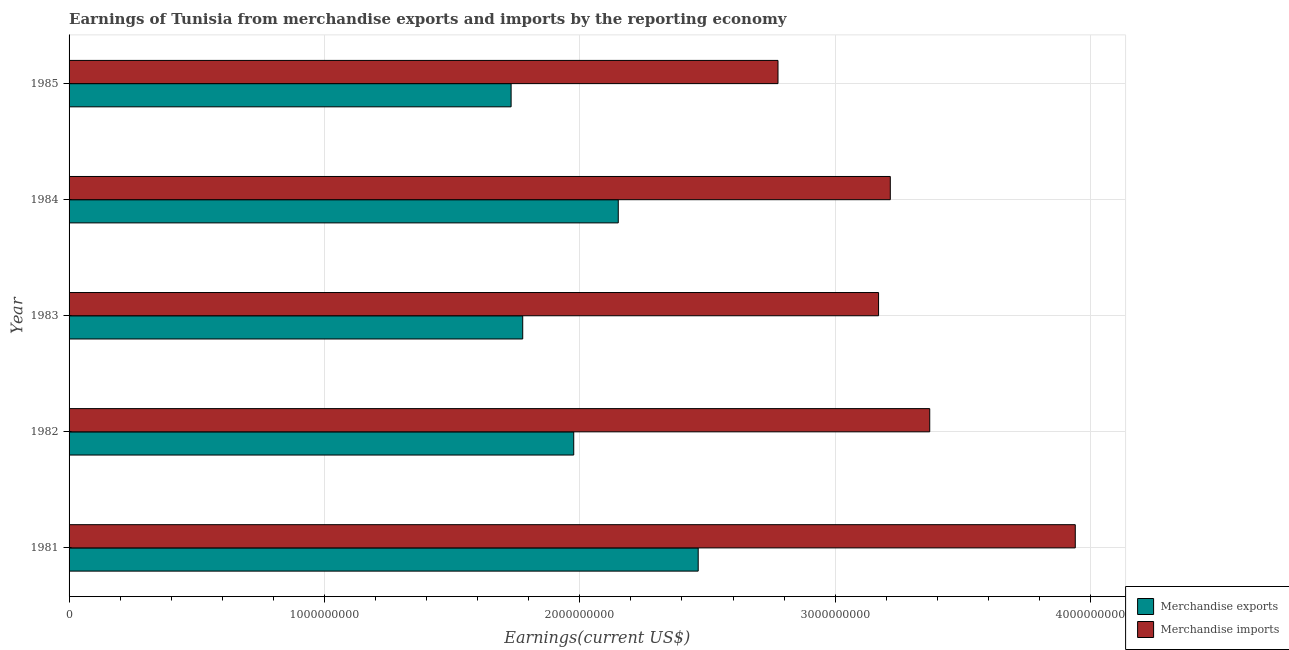How many different coloured bars are there?
Ensure brevity in your answer.  2. How many bars are there on the 2nd tick from the top?
Make the answer very short. 2. How many bars are there on the 4th tick from the bottom?
Your answer should be compact. 2. What is the label of the 1st group of bars from the top?
Keep it short and to the point. 1985. In how many cases, is the number of bars for a given year not equal to the number of legend labels?
Provide a succinct answer. 0. What is the earnings from merchandise exports in 1984?
Offer a very short reply. 2.15e+09. Across all years, what is the maximum earnings from merchandise exports?
Make the answer very short. 2.46e+09. Across all years, what is the minimum earnings from merchandise imports?
Your answer should be very brief. 2.78e+09. In which year was the earnings from merchandise exports maximum?
Provide a succinct answer. 1981. In which year was the earnings from merchandise imports minimum?
Your answer should be very brief. 1985. What is the total earnings from merchandise imports in the graph?
Provide a short and direct response. 1.65e+1. What is the difference between the earnings from merchandise exports in 1983 and that in 1985?
Your answer should be very brief. 4.54e+07. What is the difference between the earnings from merchandise exports in 1981 and the earnings from merchandise imports in 1984?
Ensure brevity in your answer.  -7.52e+08. What is the average earnings from merchandise imports per year?
Your answer should be very brief. 3.29e+09. In the year 1982, what is the difference between the earnings from merchandise exports and earnings from merchandise imports?
Offer a terse response. -1.39e+09. In how many years, is the earnings from merchandise imports greater than 1400000000 US$?
Your answer should be very brief. 5. What is the ratio of the earnings from merchandise exports in 1982 to that in 1985?
Offer a very short reply. 1.14. What is the difference between the highest and the second highest earnings from merchandise exports?
Provide a short and direct response. 3.13e+08. What is the difference between the highest and the lowest earnings from merchandise exports?
Provide a succinct answer. 7.33e+08. What does the 2nd bar from the bottom in 1981 represents?
Keep it short and to the point. Merchandise imports. How many bars are there?
Provide a short and direct response. 10. Does the graph contain any zero values?
Ensure brevity in your answer.  No. Does the graph contain grids?
Provide a succinct answer. Yes. How many legend labels are there?
Your response must be concise. 2. How are the legend labels stacked?
Make the answer very short. Vertical. What is the title of the graph?
Your answer should be very brief. Earnings of Tunisia from merchandise exports and imports by the reporting economy. What is the label or title of the X-axis?
Make the answer very short. Earnings(current US$). What is the Earnings(current US$) in Merchandise exports in 1981?
Your response must be concise. 2.46e+09. What is the Earnings(current US$) in Merchandise imports in 1981?
Your response must be concise. 3.94e+09. What is the Earnings(current US$) of Merchandise exports in 1982?
Make the answer very short. 1.98e+09. What is the Earnings(current US$) in Merchandise imports in 1982?
Your answer should be very brief. 3.37e+09. What is the Earnings(current US$) in Merchandise exports in 1983?
Give a very brief answer. 1.78e+09. What is the Earnings(current US$) in Merchandise imports in 1983?
Offer a terse response. 3.17e+09. What is the Earnings(current US$) in Merchandise exports in 1984?
Give a very brief answer. 2.15e+09. What is the Earnings(current US$) of Merchandise imports in 1984?
Offer a terse response. 3.22e+09. What is the Earnings(current US$) of Merchandise exports in 1985?
Provide a short and direct response. 1.73e+09. What is the Earnings(current US$) in Merchandise imports in 1985?
Offer a terse response. 2.78e+09. Across all years, what is the maximum Earnings(current US$) of Merchandise exports?
Make the answer very short. 2.46e+09. Across all years, what is the maximum Earnings(current US$) of Merchandise imports?
Your answer should be compact. 3.94e+09. Across all years, what is the minimum Earnings(current US$) in Merchandise exports?
Provide a short and direct response. 1.73e+09. Across all years, what is the minimum Earnings(current US$) of Merchandise imports?
Your answer should be compact. 2.78e+09. What is the total Earnings(current US$) of Merchandise exports in the graph?
Ensure brevity in your answer.  1.01e+1. What is the total Earnings(current US$) of Merchandise imports in the graph?
Your answer should be very brief. 1.65e+1. What is the difference between the Earnings(current US$) in Merchandise exports in 1981 and that in 1982?
Provide a succinct answer. 4.87e+08. What is the difference between the Earnings(current US$) of Merchandise imports in 1981 and that in 1982?
Ensure brevity in your answer.  5.70e+08. What is the difference between the Earnings(current US$) of Merchandise exports in 1981 and that in 1983?
Offer a very short reply. 6.87e+08. What is the difference between the Earnings(current US$) in Merchandise imports in 1981 and that in 1983?
Provide a short and direct response. 7.70e+08. What is the difference between the Earnings(current US$) of Merchandise exports in 1981 and that in 1984?
Give a very brief answer. 3.13e+08. What is the difference between the Earnings(current US$) of Merchandise imports in 1981 and that in 1984?
Make the answer very short. 7.24e+08. What is the difference between the Earnings(current US$) of Merchandise exports in 1981 and that in 1985?
Give a very brief answer. 7.33e+08. What is the difference between the Earnings(current US$) of Merchandise imports in 1981 and that in 1985?
Keep it short and to the point. 1.16e+09. What is the difference between the Earnings(current US$) of Merchandise exports in 1982 and that in 1983?
Give a very brief answer. 2.00e+08. What is the difference between the Earnings(current US$) of Merchandise imports in 1982 and that in 1983?
Provide a short and direct response. 2.00e+08. What is the difference between the Earnings(current US$) of Merchandise exports in 1982 and that in 1984?
Offer a very short reply. -1.74e+08. What is the difference between the Earnings(current US$) in Merchandise imports in 1982 and that in 1984?
Your answer should be compact. 1.54e+08. What is the difference between the Earnings(current US$) in Merchandise exports in 1982 and that in 1985?
Your answer should be very brief. 2.45e+08. What is the difference between the Earnings(current US$) of Merchandise imports in 1982 and that in 1985?
Offer a very short reply. 5.94e+08. What is the difference between the Earnings(current US$) of Merchandise exports in 1983 and that in 1984?
Provide a succinct answer. -3.74e+08. What is the difference between the Earnings(current US$) of Merchandise imports in 1983 and that in 1984?
Offer a terse response. -4.59e+07. What is the difference between the Earnings(current US$) in Merchandise exports in 1983 and that in 1985?
Keep it short and to the point. 4.54e+07. What is the difference between the Earnings(current US$) in Merchandise imports in 1983 and that in 1985?
Your answer should be compact. 3.94e+08. What is the difference between the Earnings(current US$) of Merchandise exports in 1984 and that in 1985?
Keep it short and to the point. 4.20e+08. What is the difference between the Earnings(current US$) in Merchandise imports in 1984 and that in 1985?
Keep it short and to the point. 4.40e+08. What is the difference between the Earnings(current US$) in Merchandise exports in 1981 and the Earnings(current US$) in Merchandise imports in 1982?
Make the answer very short. -9.07e+08. What is the difference between the Earnings(current US$) in Merchandise exports in 1981 and the Earnings(current US$) in Merchandise imports in 1983?
Keep it short and to the point. -7.06e+08. What is the difference between the Earnings(current US$) in Merchandise exports in 1981 and the Earnings(current US$) in Merchandise imports in 1984?
Provide a succinct answer. -7.52e+08. What is the difference between the Earnings(current US$) of Merchandise exports in 1981 and the Earnings(current US$) of Merchandise imports in 1985?
Make the answer very short. -3.12e+08. What is the difference between the Earnings(current US$) in Merchandise exports in 1982 and the Earnings(current US$) in Merchandise imports in 1983?
Keep it short and to the point. -1.19e+09. What is the difference between the Earnings(current US$) of Merchandise exports in 1982 and the Earnings(current US$) of Merchandise imports in 1984?
Offer a very short reply. -1.24e+09. What is the difference between the Earnings(current US$) of Merchandise exports in 1982 and the Earnings(current US$) of Merchandise imports in 1985?
Your response must be concise. -8.00e+08. What is the difference between the Earnings(current US$) of Merchandise exports in 1983 and the Earnings(current US$) of Merchandise imports in 1984?
Provide a short and direct response. -1.44e+09. What is the difference between the Earnings(current US$) of Merchandise exports in 1983 and the Earnings(current US$) of Merchandise imports in 1985?
Your response must be concise. -1.00e+09. What is the difference between the Earnings(current US$) of Merchandise exports in 1984 and the Earnings(current US$) of Merchandise imports in 1985?
Make the answer very short. -6.25e+08. What is the average Earnings(current US$) of Merchandise exports per year?
Offer a very short reply. 2.02e+09. What is the average Earnings(current US$) in Merchandise imports per year?
Ensure brevity in your answer.  3.29e+09. In the year 1981, what is the difference between the Earnings(current US$) in Merchandise exports and Earnings(current US$) in Merchandise imports?
Your answer should be very brief. -1.48e+09. In the year 1982, what is the difference between the Earnings(current US$) of Merchandise exports and Earnings(current US$) of Merchandise imports?
Provide a succinct answer. -1.39e+09. In the year 1983, what is the difference between the Earnings(current US$) in Merchandise exports and Earnings(current US$) in Merchandise imports?
Give a very brief answer. -1.39e+09. In the year 1984, what is the difference between the Earnings(current US$) of Merchandise exports and Earnings(current US$) of Merchandise imports?
Ensure brevity in your answer.  -1.07e+09. In the year 1985, what is the difference between the Earnings(current US$) of Merchandise exports and Earnings(current US$) of Merchandise imports?
Ensure brevity in your answer.  -1.05e+09. What is the ratio of the Earnings(current US$) in Merchandise exports in 1981 to that in 1982?
Your answer should be very brief. 1.25. What is the ratio of the Earnings(current US$) of Merchandise imports in 1981 to that in 1982?
Provide a succinct answer. 1.17. What is the ratio of the Earnings(current US$) of Merchandise exports in 1981 to that in 1983?
Your response must be concise. 1.39. What is the ratio of the Earnings(current US$) of Merchandise imports in 1981 to that in 1983?
Make the answer very short. 1.24. What is the ratio of the Earnings(current US$) in Merchandise exports in 1981 to that in 1984?
Your answer should be very brief. 1.15. What is the ratio of the Earnings(current US$) of Merchandise imports in 1981 to that in 1984?
Provide a short and direct response. 1.23. What is the ratio of the Earnings(current US$) in Merchandise exports in 1981 to that in 1985?
Keep it short and to the point. 1.42. What is the ratio of the Earnings(current US$) in Merchandise imports in 1981 to that in 1985?
Ensure brevity in your answer.  1.42. What is the ratio of the Earnings(current US$) of Merchandise exports in 1982 to that in 1983?
Provide a succinct answer. 1.11. What is the ratio of the Earnings(current US$) in Merchandise imports in 1982 to that in 1983?
Offer a terse response. 1.06. What is the ratio of the Earnings(current US$) in Merchandise exports in 1982 to that in 1984?
Offer a very short reply. 0.92. What is the ratio of the Earnings(current US$) of Merchandise imports in 1982 to that in 1984?
Offer a very short reply. 1.05. What is the ratio of the Earnings(current US$) of Merchandise exports in 1982 to that in 1985?
Give a very brief answer. 1.14. What is the ratio of the Earnings(current US$) of Merchandise imports in 1982 to that in 1985?
Your answer should be compact. 1.21. What is the ratio of the Earnings(current US$) in Merchandise exports in 1983 to that in 1984?
Keep it short and to the point. 0.83. What is the ratio of the Earnings(current US$) in Merchandise imports in 1983 to that in 1984?
Your answer should be very brief. 0.99. What is the ratio of the Earnings(current US$) in Merchandise exports in 1983 to that in 1985?
Your response must be concise. 1.03. What is the ratio of the Earnings(current US$) of Merchandise imports in 1983 to that in 1985?
Make the answer very short. 1.14. What is the ratio of the Earnings(current US$) in Merchandise exports in 1984 to that in 1985?
Offer a very short reply. 1.24. What is the ratio of the Earnings(current US$) of Merchandise imports in 1984 to that in 1985?
Offer a very short reply. 1.16. What is the difference between the highest and the second highest Earnings(current US$) of Merchandise exports?
Provide a short and direct response. 3.13e+08. What is the difference between the highest and the second highest Earnings(current US$) of Merchandise imports?
Keep it short and to the point. 5.70e+08. What is the difference between the highest and the lowest Earnings(current US$) in Merchandise exports?
Provide a succinct answer. 7.33e+08. What is the difference between the highest and the lowest Earnings(current US$) of Merchandise imports?
Provide a short and direct response. 1.16e+09. 